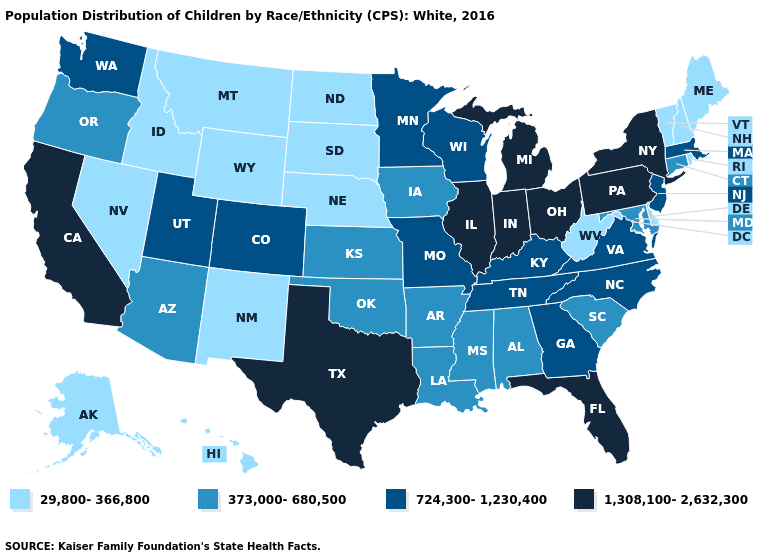Does Florida have a lower value than Colorado?
Give a very brief answer. No. What is the highest value in the USA?
Keep it brief. 1,308,100-2,632,300. What is the value of Illinois?
Short answer required. 1,308,100-2,632,300. Does Ohio have the lowest value in the MidWest?
Give a very brief answer. No. Name the states that have a value in the range 373,000-680,500?
Be succinct. Alabama, Arizona, Arkansas, Connecticut, Iowa, Kansas, Louisiana, Maryland, Mississippi, Oklahoma, Oregon, South Carolina. Does Pennsylvania have the same value as Ohio?
Short answer required. Yes. Does Texas have a higher value than Michigan?
Keep it brief. No. Which states have the lowest value in the USA?
Be succinct. Alaska, Delaware, Hawaii, Idaho, Maine, Montana, Nebraska, Nevada, New Hampshire, New Mexico, North Dakota, Rhode Island, South Dakota, Vermont, West Virginia, Wyoming. Among the states that border New Hampshire , does Vermont have the highest value?
Quick response, please. No. Among the states that border Wisconsin , does Minnesota have the highest value?
Quick response, please. No. Name the states that have a value in the range 1,308,100-2,632,300?
Give a very brief answer. California, Florida, Illinois, Indiana, Michigan, New York, Ohio, Pennsylvania, Texas. What is the lowest value in states that border Rhode Island?
Keep it brief. 373,000-680,500. Name the states that have a value in the range 373,000-680,500?
Give a very brief answer. Alabama, Arizona, Arkansas, Connecticut, Iowa, Kansas, Louisiana, Maryland, Mississippi, Oklahoma, Oregon, South Carolina. Which states hav the highest value in the MidWest?
Be succinct. Illinois, Indiana, Michigan, Ohio. 